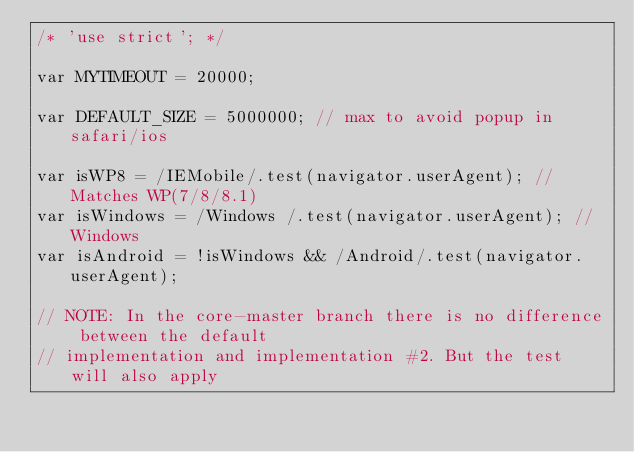Convert code to text. <code><loc_0><loc_0><loc_500><loc_500><_JavaScript_>/* 'use strict'; */

var MYTIMEOUT = 20000;

var DEFAULT_SIZE = 5000000; // max to avoid popup in safari/ios

var isWP8 = /IEMobile/.test(navigator.userAgent); // Matches WP(7/8/8.1)
var isWindows = /Windows /.test(navigator.userAgent); // Windows
var isAndroid = !isWindows && /Android/.test(navigator.userAgent);

// NOTE: In the core-master branch there is no difference between the default
// implementation and implementation #2. But the test will also apply</code> 